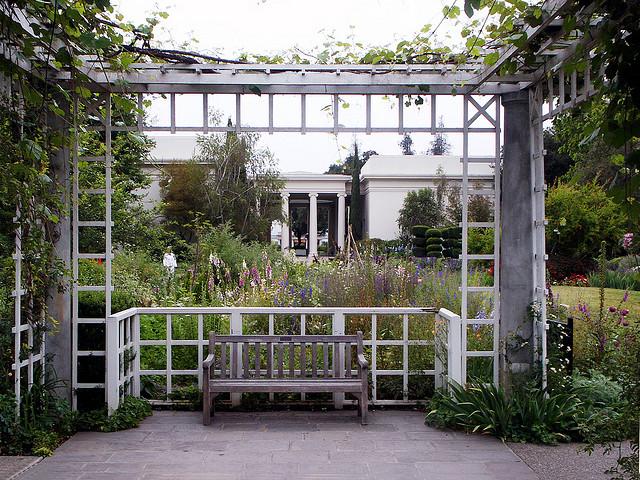Are these wild flowers?
Keep it brief. Yes. What color is the fence?
Answer briefly. White. Is this a public place?
Keep it brief. Yes. Are there animals in the photo?
Keep it brief. No. 